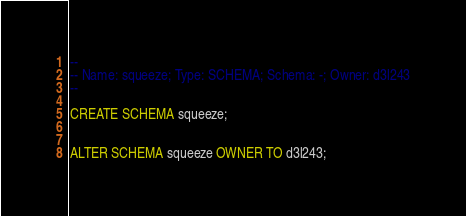<code> <loc_0><loc_0><loc_500><loc_500><_SQL_>--
-- Name: squeeze; Type: SCHEMA; Schema: -; Owner: d3l243
--

CREATE SCHEMA squeeze;


ALTER SCHEMA squeeze OWNER TO d3l243;

</code> 